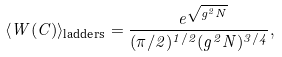<formula> <loc_0><loc_0><loc_500><loc_500>\langle W ( C ) \rangle _ { \text {ladders} } = \frac { \ e ^ { \sqrt { g ^ { 2 } N } } } { ( \pi / 2 ) ^ { 1 / 2 } ( g ^ { 2 } N ) ^ { 3 / 4 } } ,</formula> 